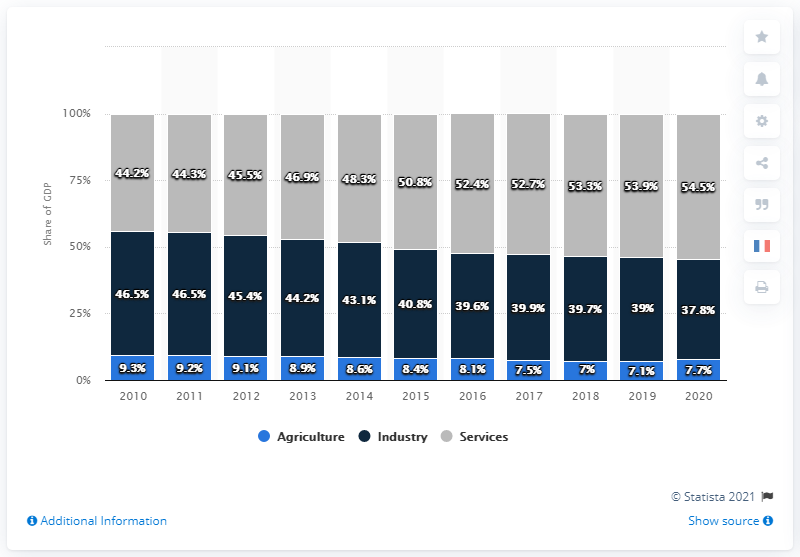Give some essential details in this illustration. In 2018, the service sector accounted for 54.5% of China's total value added. In 2018, the smallest value of the blue bar was recorded. In the period between 2010 and 2020, the economic sector that experienced the largest increase in its share of GDP was services. In 2020, agriculture accounted for 7.7% of China's Gross Domestic Product (GDP), indicating the significant contribution of the agricultural sector to the country's economy. 